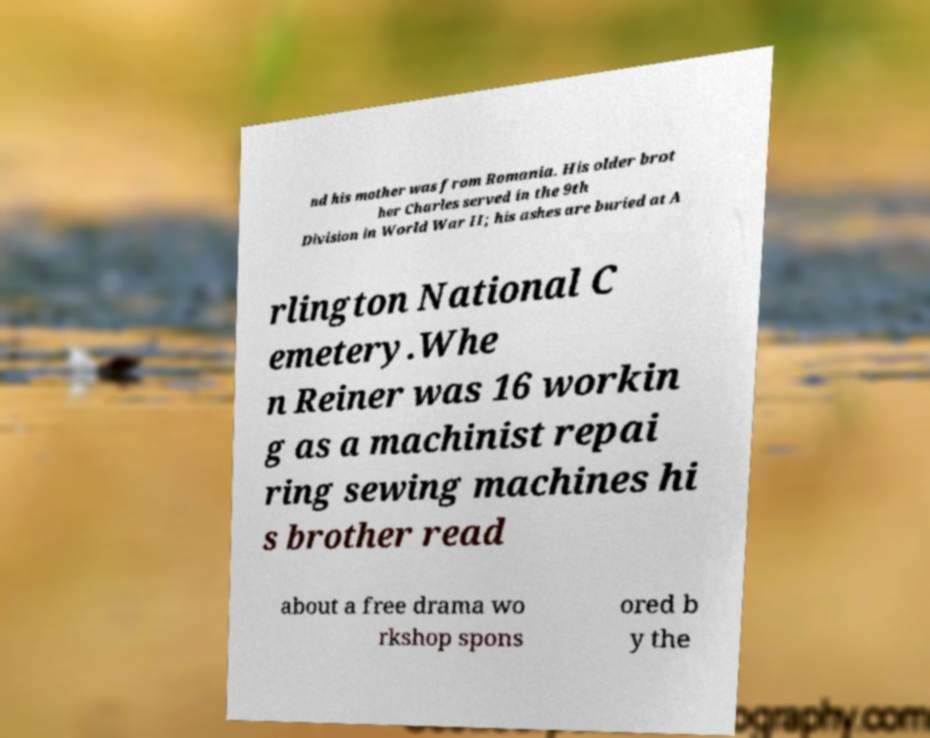Please identify and transcribe the text found in this image. nd his mother was from Romania. His older brot her Charles served in the 9th Division in World War II; his ashes are buried at A rlington National C emetery.Whe n Reiner was 16 workin g as a machinist repai ring sewing machines hi s brother read about a free drama wo rkshop spons ored b y the 